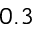<formula> <loc_0><loc_0><loc_500><loc_500>0 . 3</formula> 